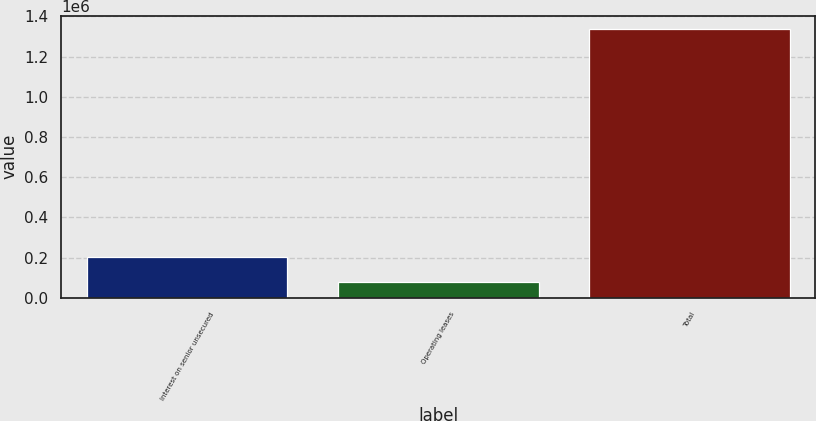<chart> <loc_0><loc_0><loc_500><loc_500><bar_chart><fcel>Interest on senior unsecured<fcel>Operating leases<fcel>Total<nl><fcel>203962<fcel>78112<fcel>1.33661e+06<nl></chart> 